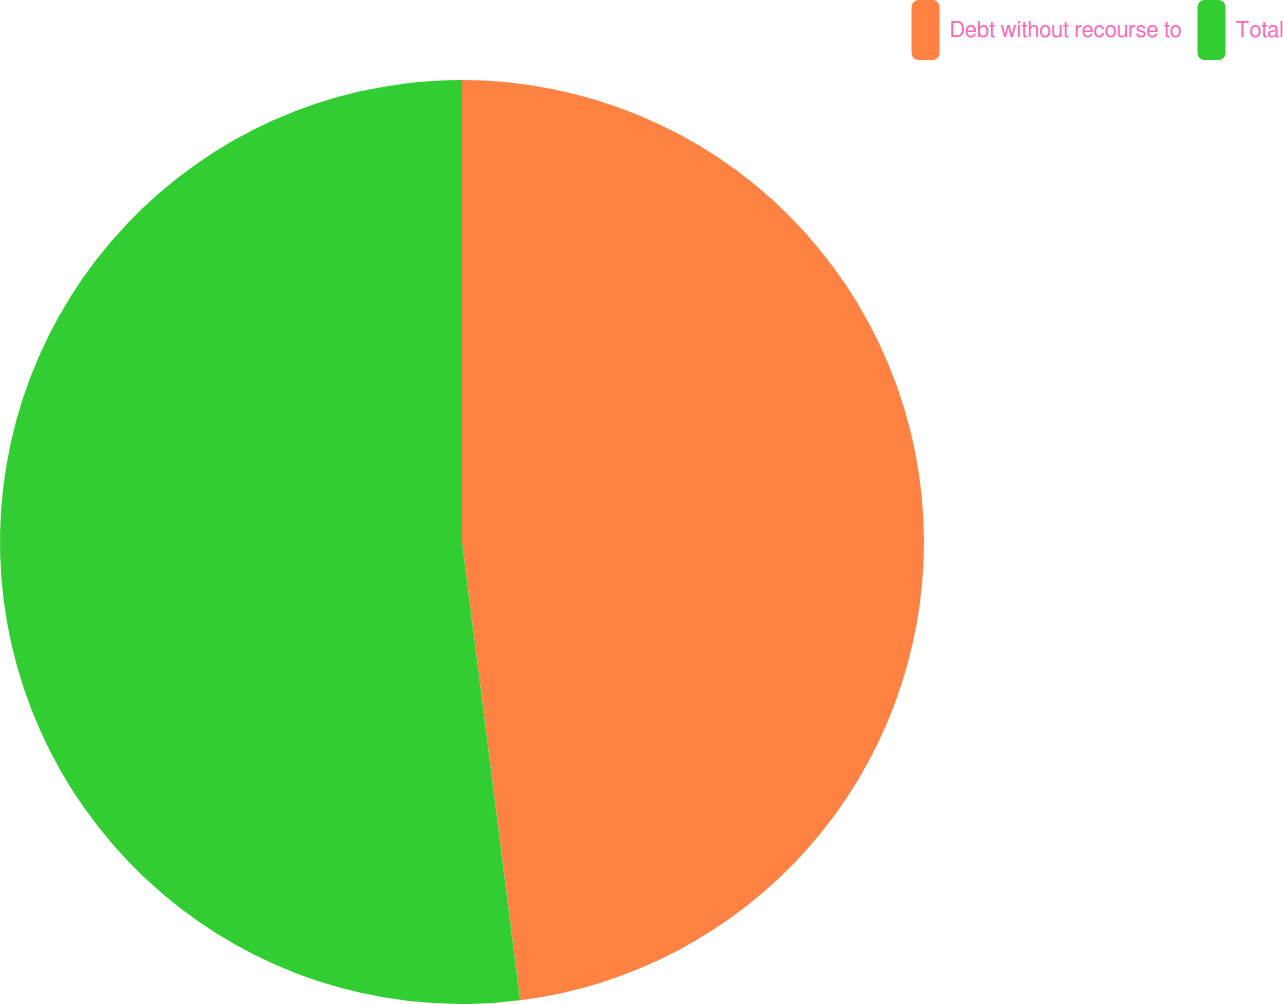Convert chart. <chart><loc_0><loc_0><loc_500><loc_500><pie_chart><fcel>Debt without recourse to<fcel>Total<nl><fcel>47.99%<fcel>52.01%<nl></chart> 